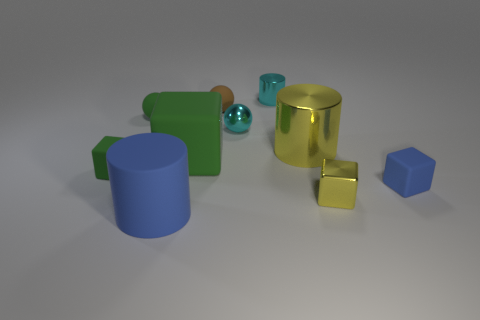Subtract 1 cubes. How many cubes are left? 3 Subtract all cylinders. How many objects are left? 7 Subtract 0 green cylinders. How many objects are left? 10 Subtract all purple metallic cubes. Subtract all green rubber spheres. How many objects are left? 9 Add 5 rubber cylinders. How many rubber cylinders are left? 6 Add 8 big gray rubber spheres. How many big gray rubber spheres exist? 8 